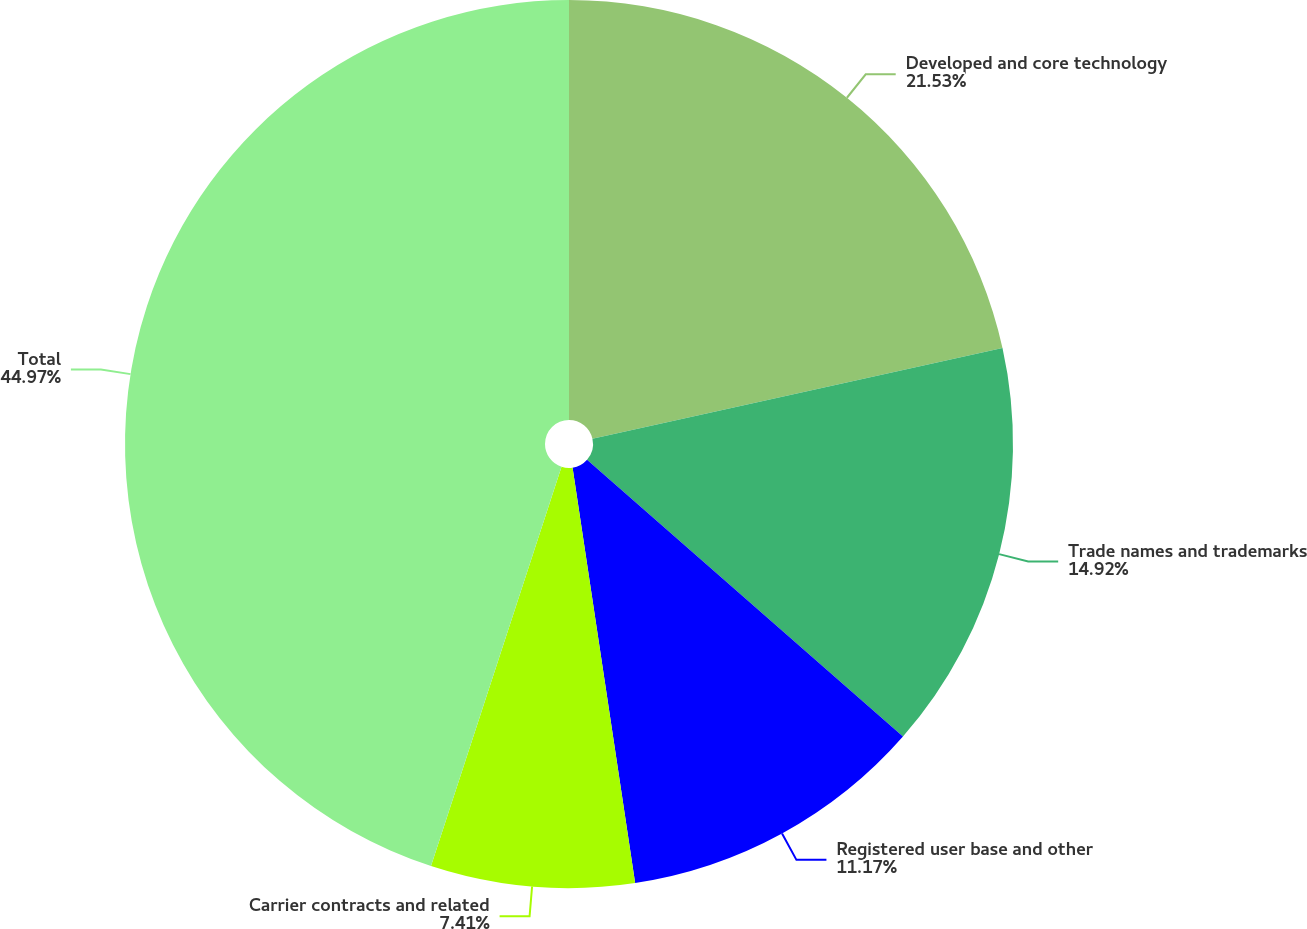<chart> <loc_0><loc_0><loc_500><loc_500><pie_chart><fcel>Developed and core technology<fcel>Trade names and trademarks<fcel>Registered user base and other<fcel>Carrier contracts and related<fcel>Total<nl><fcel>21.53%<fcel>14.92%<fcel>11.17%<fcel>7.41%<fcel>44.97%<nl></chart> 